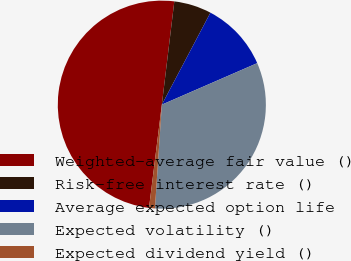Convert chart. <chart><loc_0><loc_0><loc_500><loc_500><pie_chart><fcel>Weighted-average fair value ()<fcel>Risk-free interest rate ()<fcel>Average expected option life<fcel>Expected volatility ()<fcel>Expected dividend yield ()<nl><fcel>49.95%<fcel>5.82%<fcel>10.73%<fcel>32.59%<fcel>0.91%<nl></chart> 